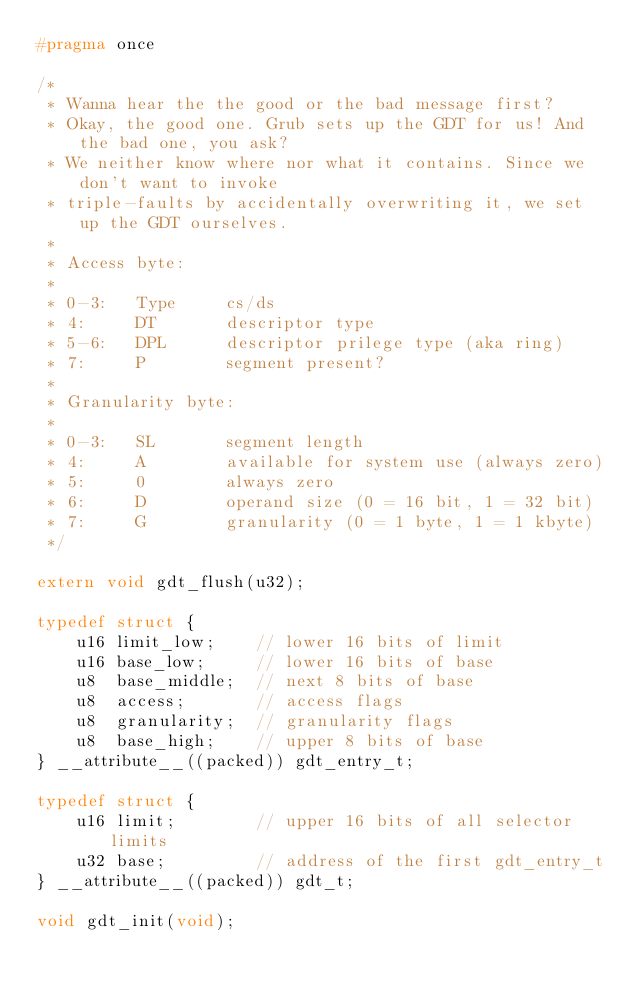<code> <loc_0><loc_0><loc_500><loc_500><_C_>#pragma once

/*
 * Wanna hear the the good or the bad message first?
 * Okay, the good one. Grub sets up the GDT for us! And the bad one, you ask?
 * We neither know where nor what it contains. Since we don't want to invoke
 * triple-faults by accidentally overwriting it, we set up the GDT ourselves.
 *
 * Access byte:
 *
 * 0-3:   Type     cs/ds
 * 4:     DT       descriptor type
 * 5-6:   DPL      descriptor prilege type (aka ring)
 * 7:     P        segment present?
 *
 * Granularity byte:
 *
 * 0-3:   SL       segment length
 * 4:     A        available for system use (always zero)
 * 5:     0        always zero
 * 6:     D        operand size (0 = 16 bit, 1 = 32 bit)
 * 7:     G        granularity (0 = 1 byte, 1 = 1 kbyte)
 */

extern void gdt_flush(u32);

typedef struct {
    u16 limit_low;    // lower 16 bits of limit
    u16 base_low;     // lower 16 bits of base
    u8  base_middle;  // next 8 bits of base
    u8  access;       // access flags
    u8  granularity;  // granularity flags
    u8  base_high;    // upper 8 bits of base
} __attribute__((packed)) gdt_entry_t;

typedef struct {
    u16 limit;        // upper 16 bits of all selector limits
    u32 base;         // address of the first gdt_entry_t
} __attribute__((packed)) gdt_t;

void gdt_init(void);
</code> 